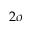<formula> <loc_0><loc_0><loc_500><loc_500>2 \sigma</formula> 